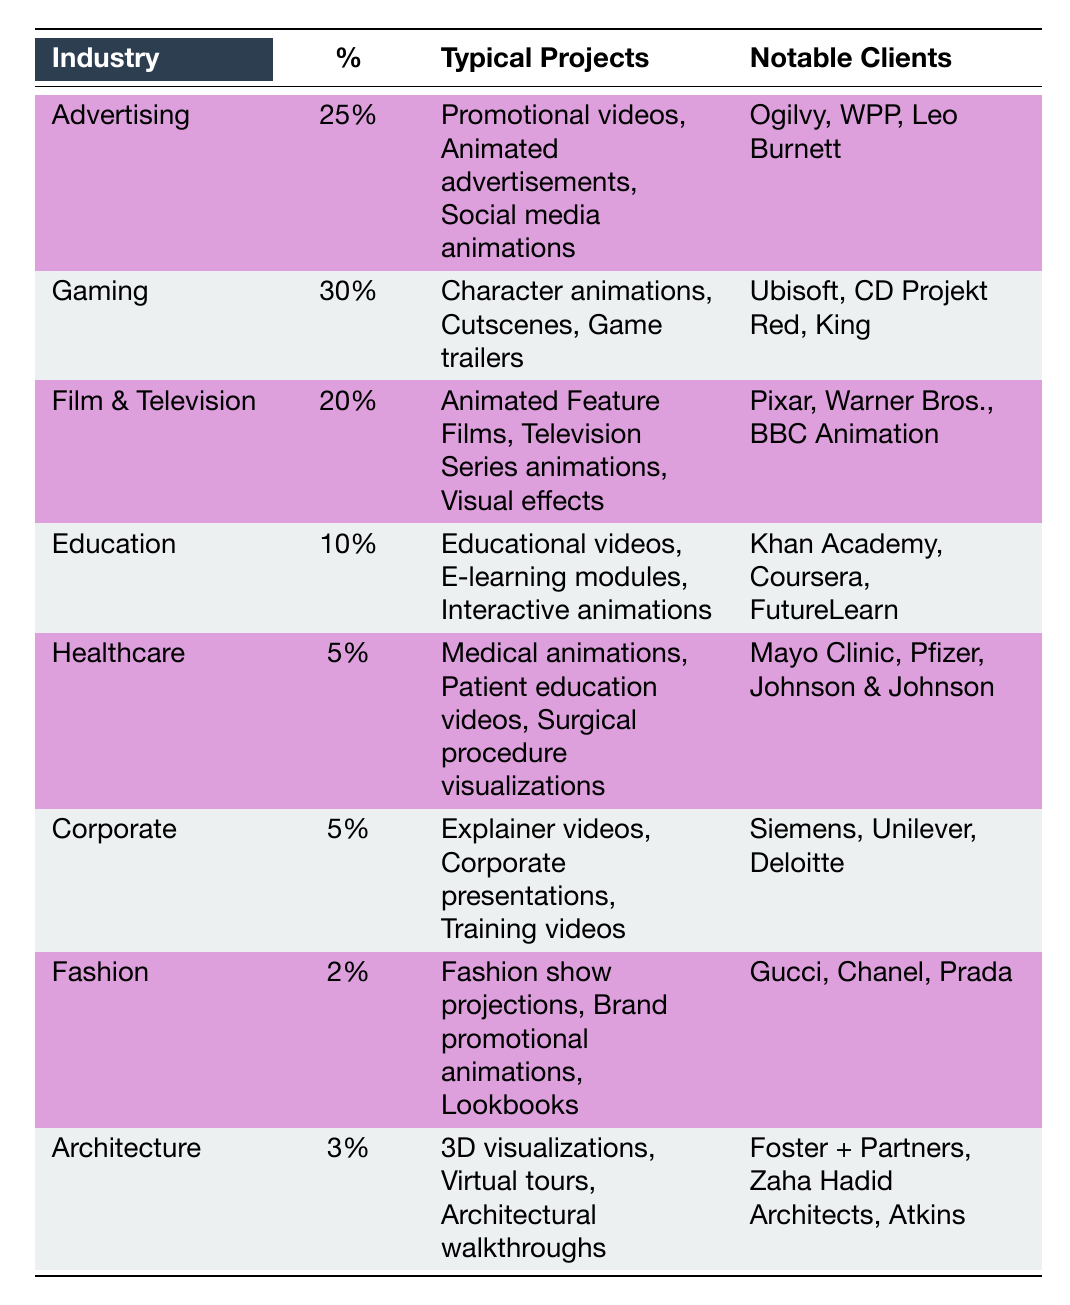What's the percentage of clients in the Gaming industry? The table shows the percentage for each industry. For Gaming, the percentage is directly listed as 30%.
Answer: 30% What typical projects are associated with the Advertising industry? The typical projects for Advertising, listed in the table, are promotional videos, animated advertisements, and social media animations.
Answer: Promotional videos, animated advertisements, social media animations What are the notable clients in the Film & Television industry? The table specifies notable clients for Film & Television, which include Pixar, Warner Bros., and BBC Animation.
Answer: Pixar, Warner Bros., BBC Animation Is the percentage of work from the Healthcare industry greater than that from the Fashion industry? The Healthcare industry has a percentage of 5%, while the Fashion industry has a percentage of 2%. Since 5% is greater than 2%, the statement is true.
Answer: Yes What is the total percentage of clients in the Corporate and Healthcare industries combined? The table provides the percentages as 5% for Corporate and 5% for Healthcare. To find the total, we add these together: 5% + 5% = 10%.
Answer: 10% Which industry has the highest percentage of freelance 3D animator clients? By examining the percentages listed in the table, Gaming has the highest percentage at 30%.
Answer: Gaming Based on the table, do more clients come from Education or Film & Television? The Education industry has 10%, while Film & Television has 20%. Since 20% is greater than 10%, more clients come from Film & Television.
Answer: Film & Television What is the combined percentage of industries that are less than 5%? The table indicates that Healthcare has 5%, Corporate has 5%, Fashion has 2%, and Architecture has 3%. The only industry less than 5% is Fashion and Architecture: 2% + 3% = 5%.
Answer: 5% Which industry has the fewest notable clients listed? The Fashion industry has three notable clients listed (Gucci, Chanel, and Prada), which is the same as other industries. However, Corporate also has three notable clients. The question is how to interpret 'fewer.' Since they are tied, the answer reflects that no industry has fewer than three.
Answer: None, all have three 